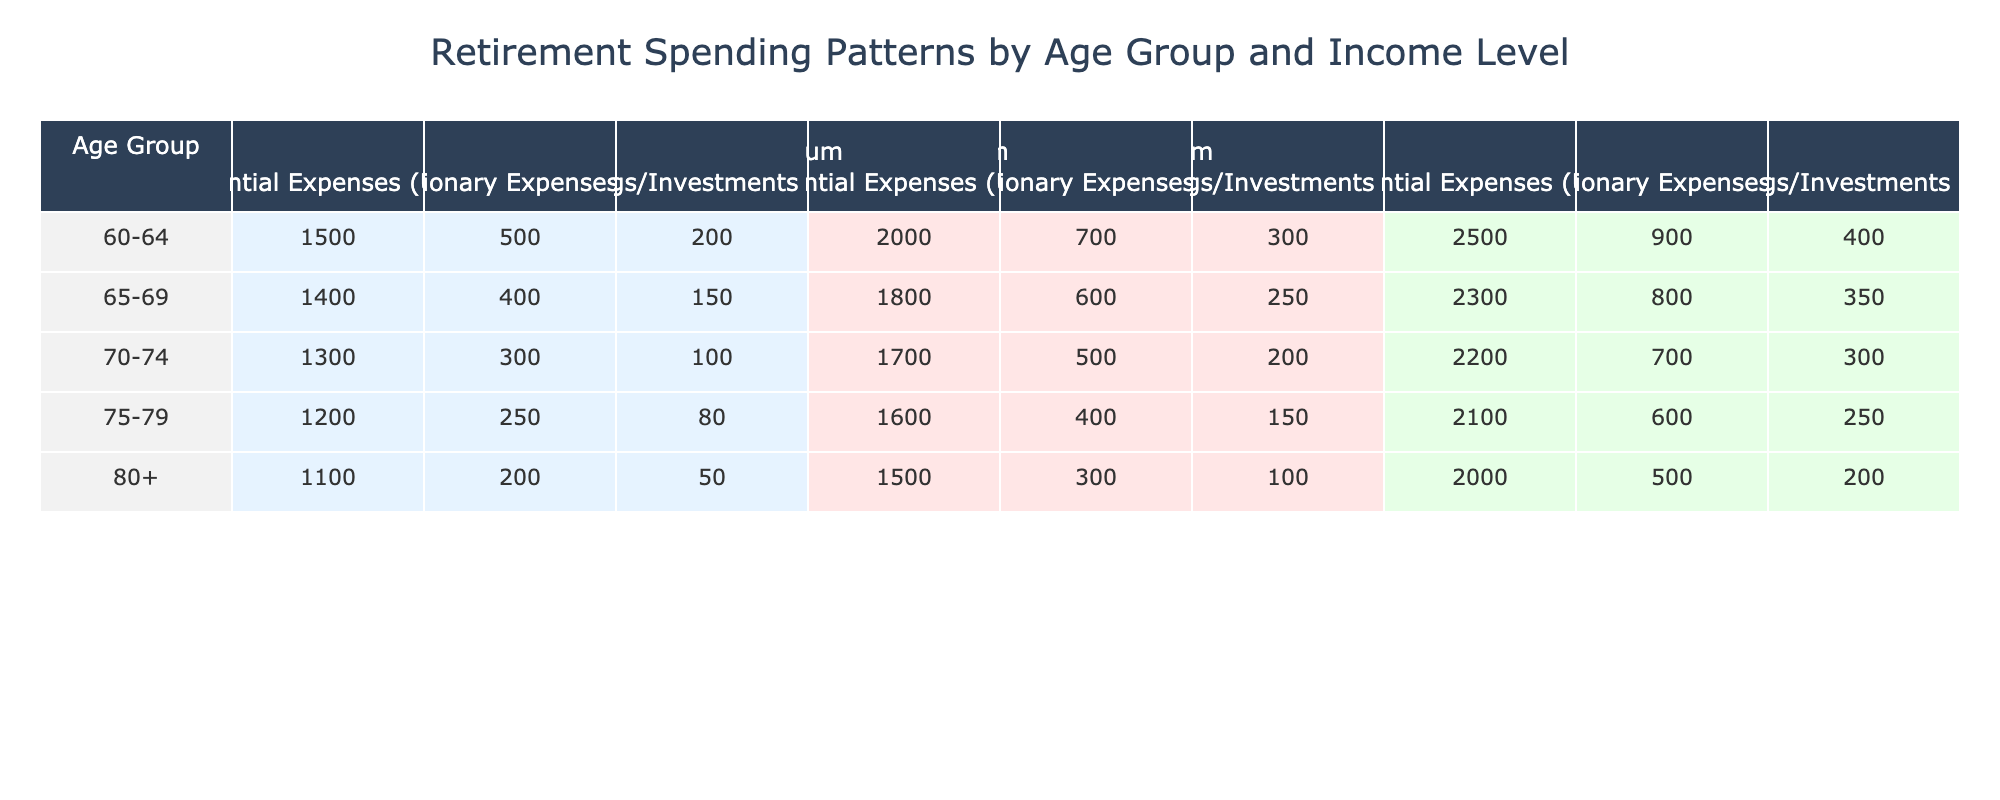What are the essential expenses for the 70-74 age group with a high income level? According to the table, for the age group 70-74 and high income level, the essential expenses are given as 2200 USD.
Answer: 2200 Which age group has the lowest discretionary expenses at the medium income level? For the medium income level, we can see the values. The 60-64 age group's discretionary expenses are 700, the 65-69 age group's are 600, the 70-74 age group's are 500, and the 75-79 age group's are 400. The lowest discretionary expenses are therefore in the 75-79 age group at 400 USD.
Answer: 400 What is the total essential expense for all age groups combined at the low income level? We will sum the essential expenses for the low income level across all age groups: 1500 (60-64) + 1400 (65-69) + 1300 (70-74) + 1200 (75-79) + 1100 (80+) = 6500 USD.
Answer: 6500 Is the average discretionary expense for the 80+ age group greater than 300 USD? The discretionary expenses for the 80+ age group are 200 (Low), 300 (Medium), and 500 (High). Calculating the average: (200 + 300 + 500) / 3 = 333.33 USD, which is greater than 300.
Answer: Yes What is the difference in savings/investments between the high income level for the 60-64 and 70-74 age groups? The savings/investments for the 60-64 age group at high income level is 400 USD and for the 70-74 age group at high income level is 300 USD. The difference is 400 - 300 = 100 USD.
Answer: 100 What is the average savings/investments across all age groups for the medium income level? For medium income level: 300 (60-64) + 250 (65-69) + 200 (70-74) + 150 (75-79) + 100 (80+) = 1000 USD. There are 5 age groups, so the average is 1000 / 5 = 200 USD.
Answer: 200 Which income level has the highest essential expenses for the age group 65-69? Referring to the table: 1400 (Low), 1800 (Medium), and 2300 (High). The highest essential expenses for the 65-69 age group is thus 2300 USD at the high income level.
Answer: 2300 How much more does the 75-79 age group spend on discretionary expenses compared to the 70-74 age group at the low income level? For the low income level, the 75-79 age group has discretionary expenses of 250 USD, while the 70-74 age group has 300 USD. The difference is 300 - 250 = 50 USD, meaning the 70-74 age group spends more.
Answer: 50 